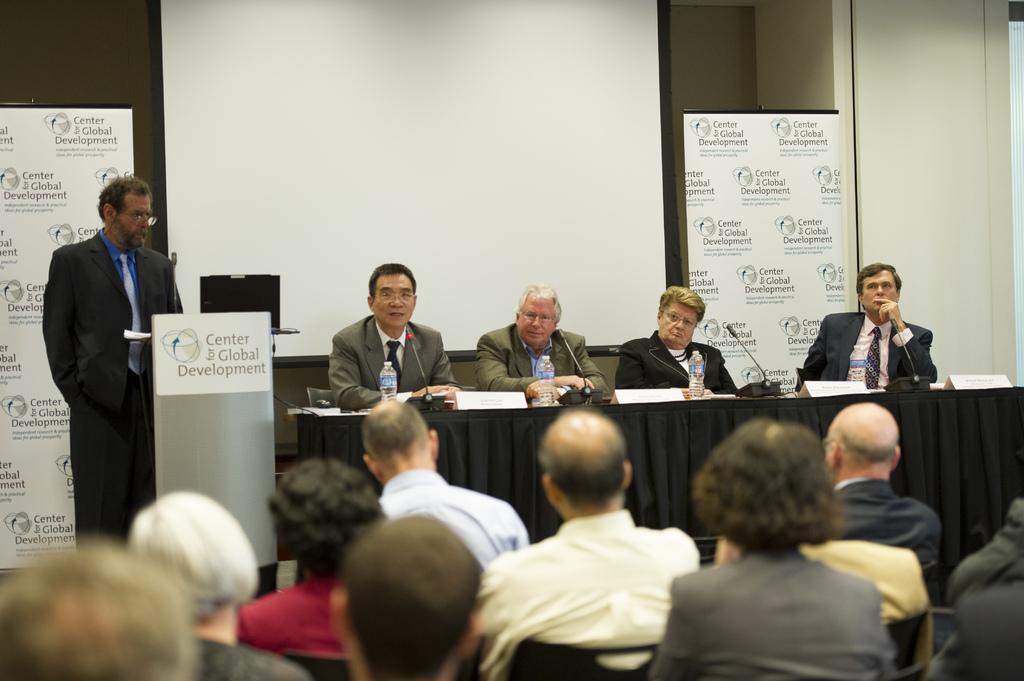How would you summarize this image in a sentence or two? Here we can see few persons are sitting on the chairs and there is a man standing on the floor. There is a table. On the table we can see a cloth, name boards, bottles, and mike's. There is a podium. In the background we can see banners, monitor, screen, and wall. 